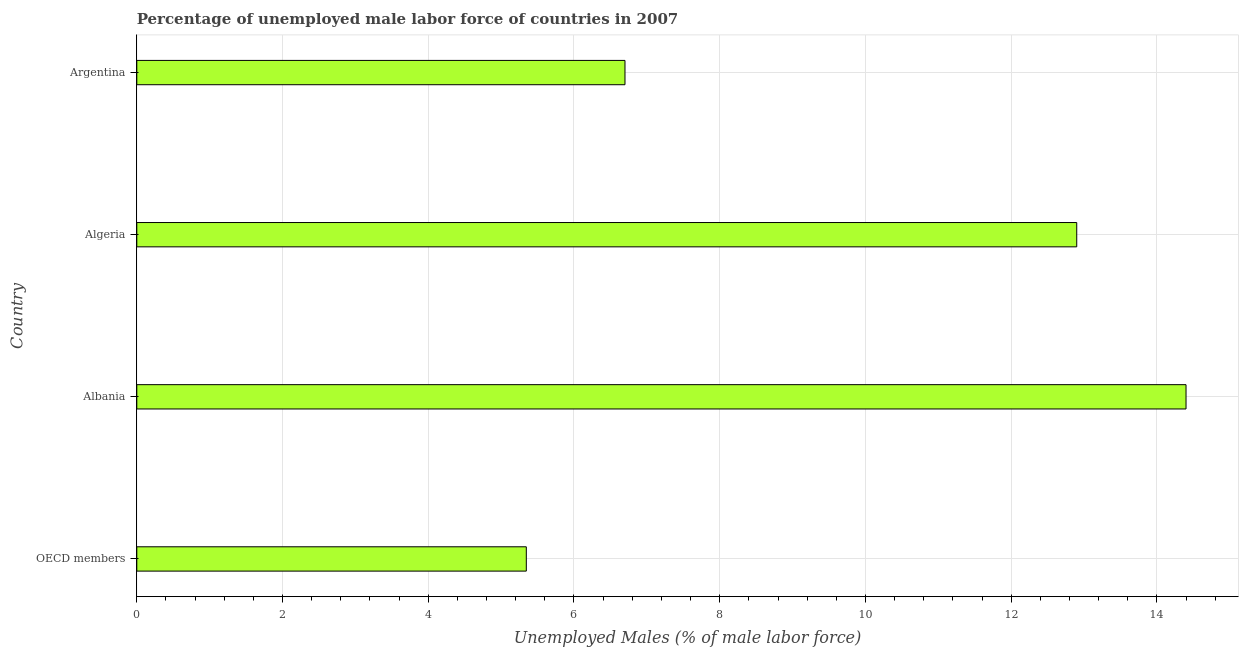What is the title of the graph?
Offer a terse response. Percentage of unemployed male labor force of countries in 2007. What is the label or title of the X-axis?
Provide a short and direct response. Unemployed Males (% of male labor force). What is the total unemployed male labour force in Albania?
Your answer should be compact. 14.4. Across all countries, what is the maximum total unemployed male labour force?
Provide a short and direct response. 14.4. Across all countries, what is the minimum total unemployed male labour force?
Give a very brief answer. 5.35. In which country was the total unemployed male labour force maximum?
Offer a very short reply. Albania. What is the sum of the total unemployed male labour force?
Ensure brevity in your answer.  39.35. What is the difference between the total unemployed male labour force in Albania and Algeria?
Offer a terse response. 1.5. What is the average total unemployed male labour force per country?
Give a very brief answer. 9.84. What is the median total unemployed male labour force?
Ensure brevity in your answer.  9.8. In how many countries, is the total unemployed male labour force greater than 8.4 %?
Offer a terse response. 2. What is the ratio of the total unemployed male labour force in Argentina to that in OECD members?
Offer a very short reply. 1.25. Is the total unemployed male labour force in Albania less than that in Algeria?
Keep it short and to the point. No. Is the difference between the total unemployed male labour force in Albania and OECD members greater than the difference between any two countries?
Your answer should be compact. Yes. What is the difference between the highest and the second highest total unemployed male labour force?
Provide a short and direct response. 1.5. Is the sum of the total unemployed male labour force in Albania and Argentina greater than the maximum total unemployed male labour force across all countries?
Your response must be concise. Yes. What is the difference between the highest and the lowest total unemployed male labour force?
Ensure brevity in your answer.  9.05. How many bars are there?
Offer a very short reply. 4. How many countries are there in the graph?
Your response must be concise. 4. Are the values on the major ticks of X-axis written in scientific E-notation?
Ensure brevity in your answer.  No. What is the Unemployed Males (% of male labor force) of OECD members?
Your response must be concise. 5.35. What is the Unemployed Males (% of male labor force) in Albania?
Offer a very short reply. 14.4. What is the Unemployed Males (% of male labor force) in Algeria?
Your answer should be compact. 12.9. What is the Unemployed Males (% of male labor force) in Argentina?
Provide a short and direct response. 6.7. What is the difference between the Unemployed Males (% of male labor force) in OECD members and Albania?
Your response must be concise. -9.05. What is the difference between the Unemployed Males (% of male labor force) in OECD members and Algeria?
Your answer should be compact. -7.55. What is the difference between the Unemployed Males (% of male labor force) in OECD members and Argentina?
Give a very brief answer. -1.35. What is the difference between the Unemployed Males (% of male labor force) in Algeria and Argentina?
Ensure brevity in your answer.  6.2. What is the ratio of the Unemployed Males (% of male labor force) in OECD members to that in Albania?
Your response must be concise. 0.37. What is the ratio of the Unemployed Males (% of male labor force) in OECD members to that in Algeria?
Make the answer very short. 0.41. What is the ratio of the Unemployed Males (% of male labor force) in OECD members to that in Argentina?
Give a very brief answer. 0.8. What is the ratio of the Unemployed Males (% of male labor force) in Albania to that in Algeria?
Your answer should be very brief. 1.12. What is the ratio of the Unemployed Males (% of male labor force) in Albania to that in Argentina?
Ensure brevity in your answer.  2.15. What is the ratio of the Unemployed Males (% of male labor force) in Algeria to that in Argentina?
Give a very brief answer. 1.93. 